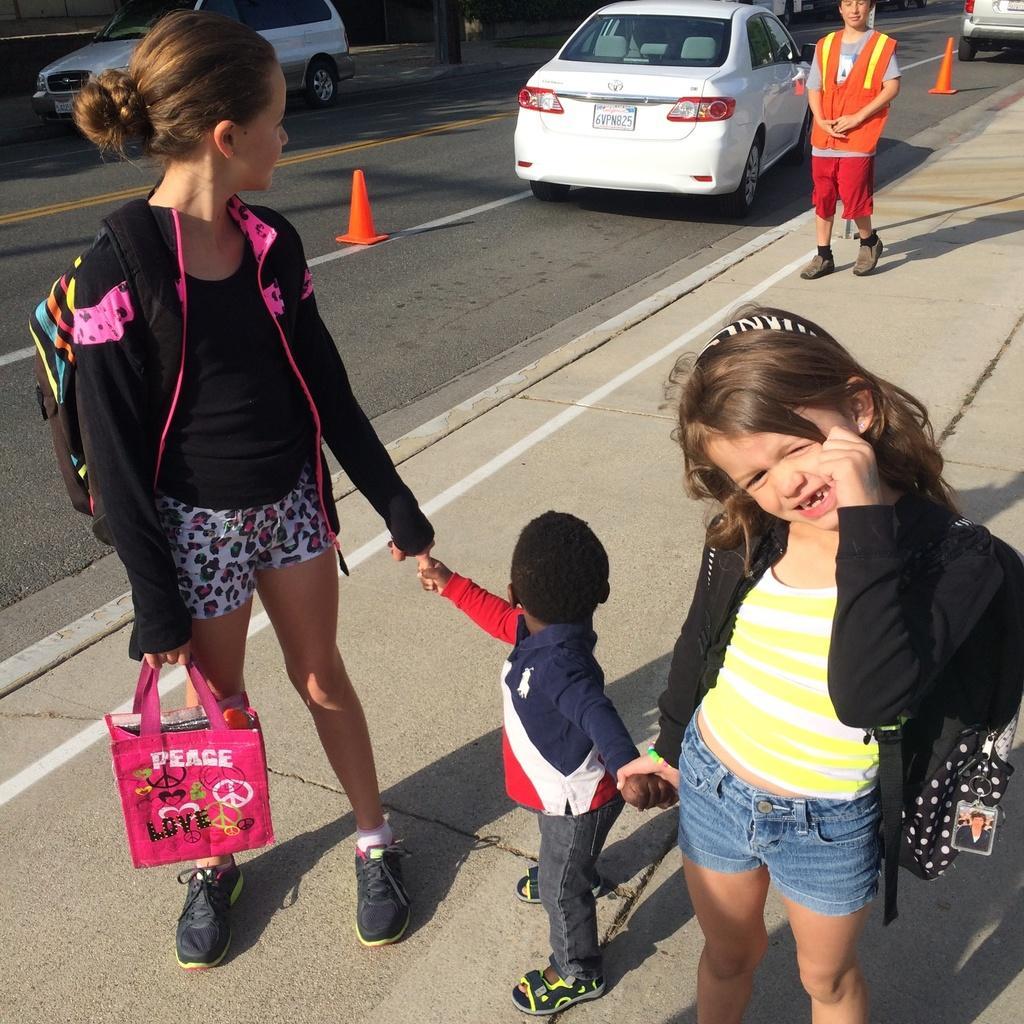Could you give a brief overview of what you see in this image? In the image there are three people in the foreground, they are standing on the footpath and behind them there is another person and beside the footpath there are vehicles on the road. 